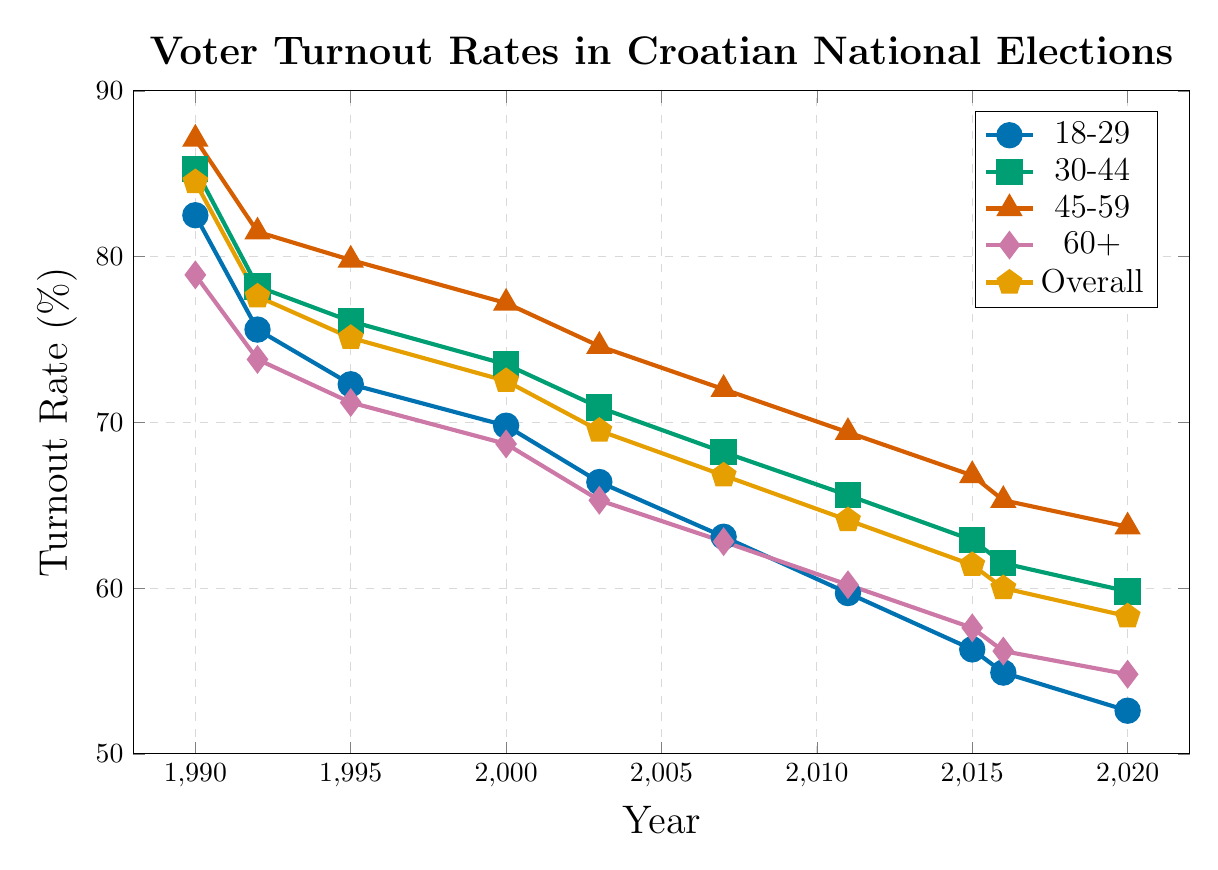What was the overall voter turnout rate in the 1990 election? We look at the value corresponding to "Overall" in the year 1990 in the figure. The value is 84.5%.
Answer: 84.5% How did the voter turnout rate for the 18-29 age group in 2020 compare to that in 1990? We compare the values for the 18-29 age group in the years 1990 and 2020. In 1990, the rate was 82.5%, and in 2020, it was 52.6%.
Answer: The turnout rate decreased Which age group had the highest voter turnout rate in the 1995 election? We identify the highest value among the age groups in the year 1995. The values are: 18-29 (72.3%), 30-44 (76.1%), 45-59 (79.8%), 60+ (71.2%). The highest value is 79.8% for the 45-59 age group.
Answer: 45-59 What is the difference between the voter turnout rates for the 60+ age group and the overall turnout rate in 2003? We find the values for the 60+ age group (65.3%) and the overall turnout rate (69.5%) in the 2003 data. The difference is 69.5% - 65.3% = 4.2%.
Answer: 4.2% Which age group showed the greatest decline in voter turnout rate from 1990 to 2020? We calculate the differences in turnout rates from 1990 to 2020 for each age group: 18-29 (82.5% - 52.6% = 29.9%), 30-44 (85.3% - 59.8% = 25.5%), 45-59 (87.1% - 63.7% = 23.4%), 60+ (78.9% - 54.8% = 24.1%). The greatest decline is 29.9% for the 18-29 age group.
Answer: 18-29 What was the trend in overall voter turnout rates from 1990 to 2020? Observing the overall voter turnout rates, the trend shows a consistent decline from 84.5% in 1990 to 58.3% in 2020.
Answer: Declining In which election year did the 30-44 age group have a voter turnout rate closest to 70%? We look for the value closest to 70% for the 30-44 age group: In 2000 (73.5%), 2003 (70.9%), 2007 (68.2%), 2011 (65.6%). The closest value is 70.9% in 2003.
Answer: 2003 Did any age groups have an increasing voter turnout rate in any given year-to-year interval? We analyze each age group for year-to-year intervals to identify any increases: 
- 18-29: No increasing intervals.
- 30-44: No increasing intervals.
- 45-59: No increasing intervals.
- 60+: No increasing intervals.
Answer: No Which age group had the smallest decline in voter turnout rates from 2016 to 2020? We calculate the differences in turnout rates between 2016 and 2020 for each age group: 18-29 (54.9% - 52.6% = 2.3%), 30-44 (61.5% - 59.8% = 1.7%), 45-59 (65.3% - 63.7% = 1.6%), 60+ (56.2% - 54.8% = 1.4%). The smallest decline is 1.4% for the 60+ age group.
Answer: 60+ 